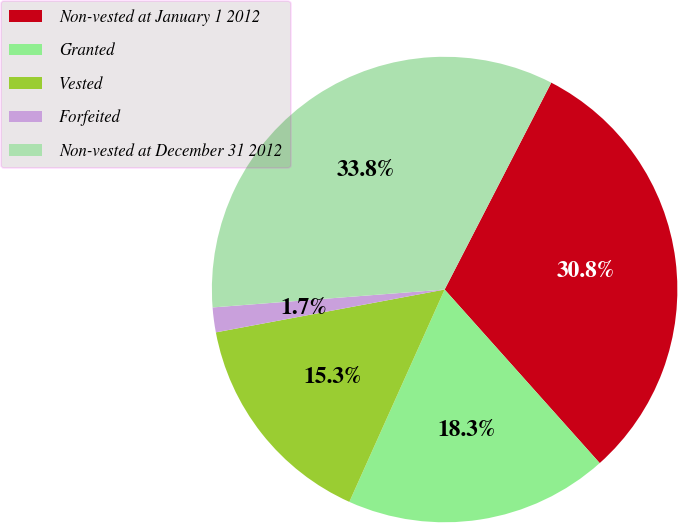<chart> <loc_0><loc_0><loc_500><loc_500><pie_chart><fcel>Non-vested at January 1 2012<fcel>Granted<fcel>Vested<fcel>Forfeited<fcel>Non-vested at December 31 2012<nl><fcel>30.82%<fcel>18.32%<fcel>15.34%<fcel>1.72%<fcel>33.8%<nl></chart> 